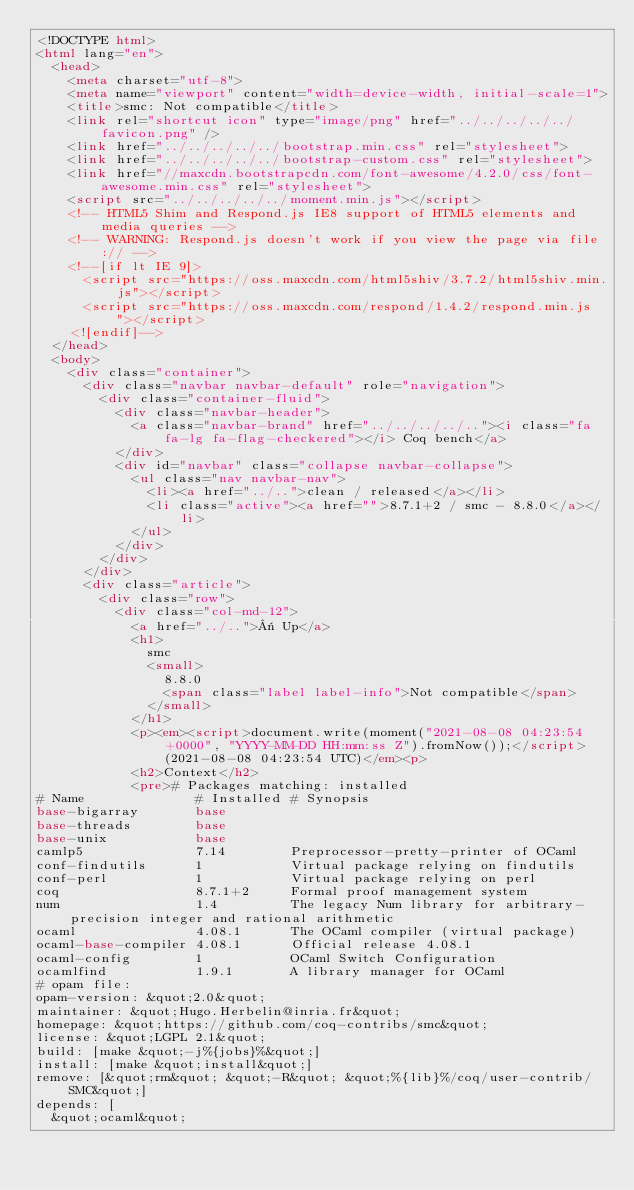Convert code to text. <code><loc_0><loc_0><loc_500><loc_500><_HTML_><!DOCTYPE html>
<html lang="en">
  <head>
    <meta charset="utf-8">
    <meta name="viewport" content="width=device-width, initial-scale=1">
    <title>smc: Not compatible</title>
    <link rel="shortcut icon" type="image/png" href="../../../../../favicon.png" />
    <link href="../../../../../bootstrap.min.css" rel="stylesheet">
    <link href="../../../../../bootstrap-custom.css" rel="stylesheet">
    <link href="//maxcdn.bootstrapcdn.com/font-awesome/4.2.0/css/font-awesome.min.css" rel="stylesheet">
    <script src="../../../../../moment.min.js"></script>
    <!-- HTML5 Shim and Respond.js IE8 support of HTML5 elements and media queries -->
    <!-- WARNING: Respond.js doesn't work if you view the page via file:// -->
    <!--[if lt IE 9]>
      <script src="https://oss.maxcdn.com/html5shiv/3.7.2/html5shiv.min.js"></script>
      <script src="https://oss.maxcdn.com/respond/1.4.2/respond.min.js"></script>
    <![endif]-->
  </head>
  <body>
    <div class="container">
      <div class="navbar navbar-default" role="navigation">
        <div class="container-fluid">
          <div class="navbar-header">
            <a class="navbar-brand" href="../../../../.."><i class="fa fa-lg fa-flag-checkered"></i> Coq bench</a>
          </div>
          <div id="navbar" class="collapse navbar-collapse">
            <ul class="nav navbar-nav">
              <li><a href="../..">clean / released</a></li>
              <li class="active"><a href="">8.7.1+2 / smc - 8.8.0</a></li>
            </ul>
          </div>
        </div>
      </div>
      <div class="article">
        <div class="row">
          <div class="col-md-12">
            <a href="../..">« Up</a>
            <h1>
              smc
              <small>
                8.8.0
                <span class="label label-info">Not compatible</span>
              </small>
            </h1>
            <p><em><script>document.write(moment("2021-08-08 04:23:54 +0000", "YYYY-MM-DD HH:mm:ss Z").fromNow());</script> (2021-08-08 04:23:54 UTC)</em><p>
            <h2>Context</h2>
            <pre># Packages matching: installed
# Name              # Installed # Synopsis
base-bigarray       base
base-threads        base
base-unix           base
camlp5              7.14        Preprocessor-pretty-printer of OCaml
conf-findutils      1           Virtual package relying on findutils
conf-perl           1           Virtual package relying on perl
coq                 8.7.1+2     Formal proof management system
num                 1.4         The legacy Num library for arbitrary-precision integer and rational arithmetic
ocaml               4.08.1      The OCaml compiler (virtual package)
ocaml-base-compiler 4.08.1      Official release 4.08.1
ocaml-config        1           OCaml Switch Configuration
ocamlfind           1.9.1       A library manager for OCaml
# opam file:
opam-version: &quot;2.0&quot;
maintainer: &quot;Hugo.Herbelin@inria.fr&quot;
homepage: &quot;https://github.com/coq-contribs/smc&quot;
license: &quot;LGPL 2.1&quot;
build: [make &quot;-j%{jobs}%&quot;]
install: [make &quot;install&quot;]
remove: [&quot;rm&quot; &quot;-R&quot; &quot;%{lib}%/coq/user-contrib/SMC&quot;]
depends: [
  &quot;ocaml&quot;</code> 